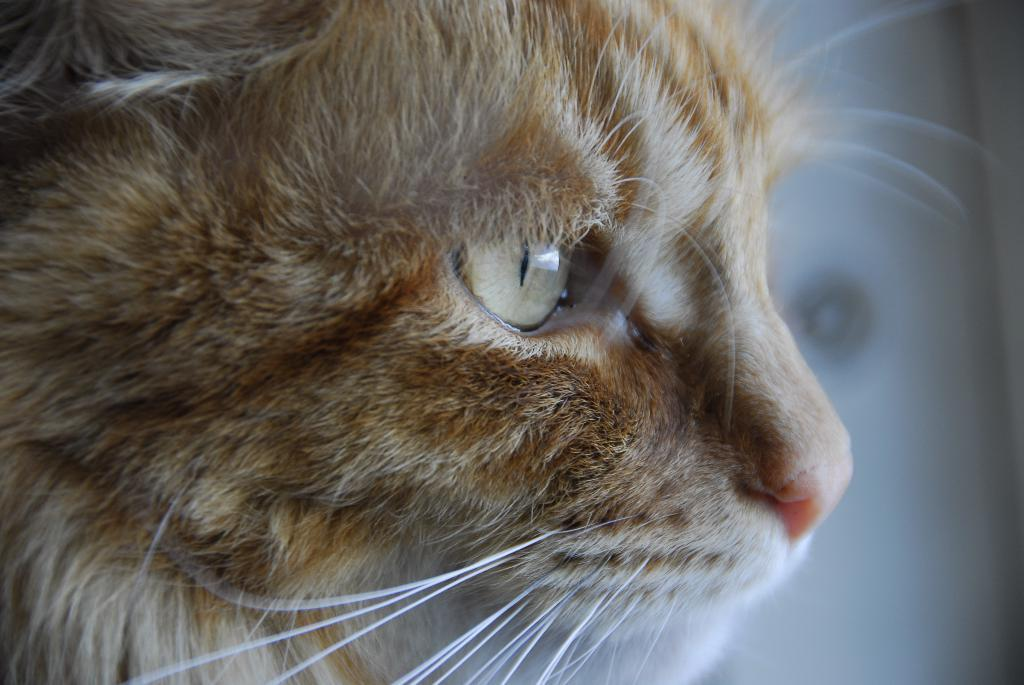What is the main subject of the image? The main subject of the image is a cat's face. What color is the background of the image? The background of the image is white. What time of day is depicted in the image? The image does not depict a specific time of day, as it only shows a cat's face against a white background. What type of milk is being consumed by the cat in the image? There is no milk present in the image, as it only shows a cat's face against a white background. 